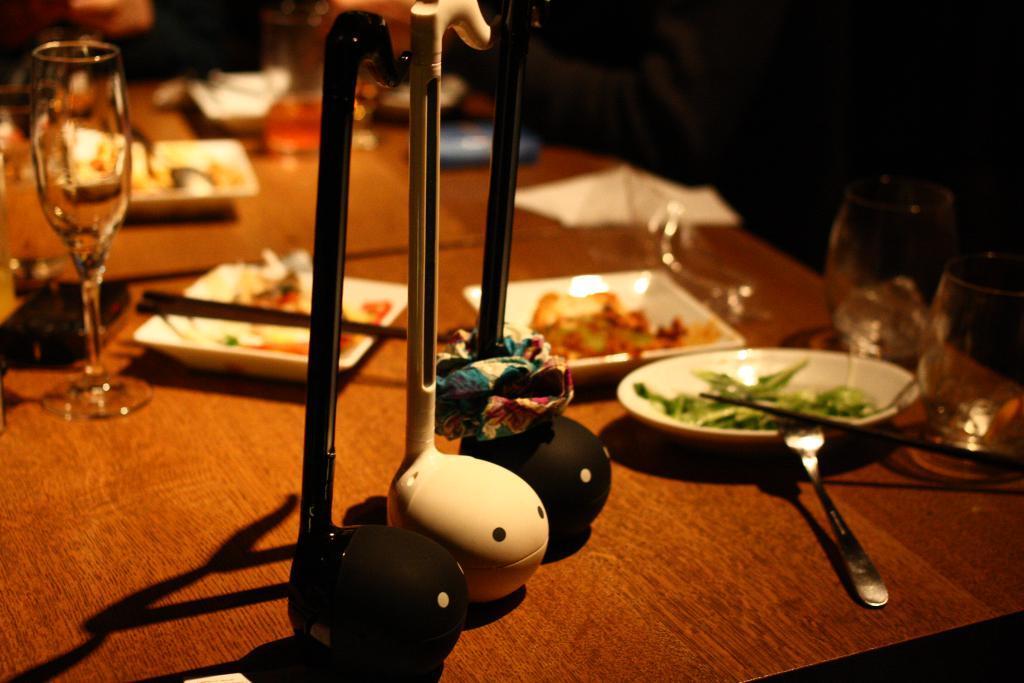Can you describe this image briefly? The picture is clicked inside a restaurant where there are food eatables on top of the table and there are three unique stands placed on the table. 